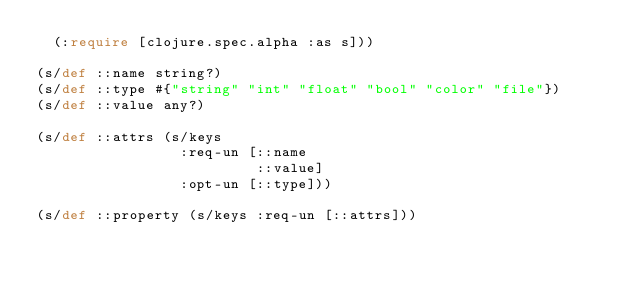Convert code to text. <code><loc_0><loc_0><loc_500><loc_500><_Clojure_>  (:require [clojure.spec.alpha :as s]))

(s/def ::name string?)
(s/def ::type #{"string" "int" "float" "bool" "color" "file"})
(s/def ::value any?)

(s/def ::attrs (s/keys
                 :req-un [::name
                          ::value]
                 :opt-un [::type]))

(s/def ::property (s/keys :req-un [::attrs]))

</code> 